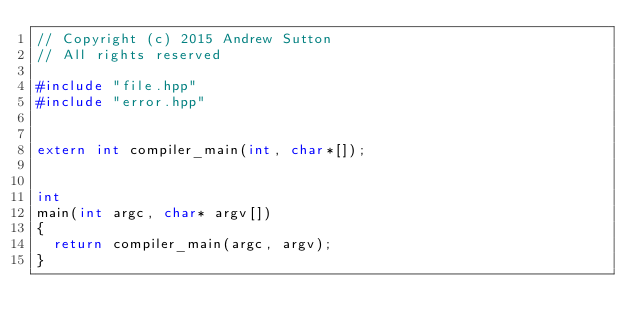Convert code to text. <code><loc_0><loc_0><loc_500><loc_500><_C++_>// Copyright (c) 2015 Andrew Sutton
// All rights reserved

#include "file.hpp"
#include "error.hpp"


extern int compiler_main(int, char*[]);


int
main(int argc, char* argv[])
{
  return compiler_main(argc, argv);
}
</code> 